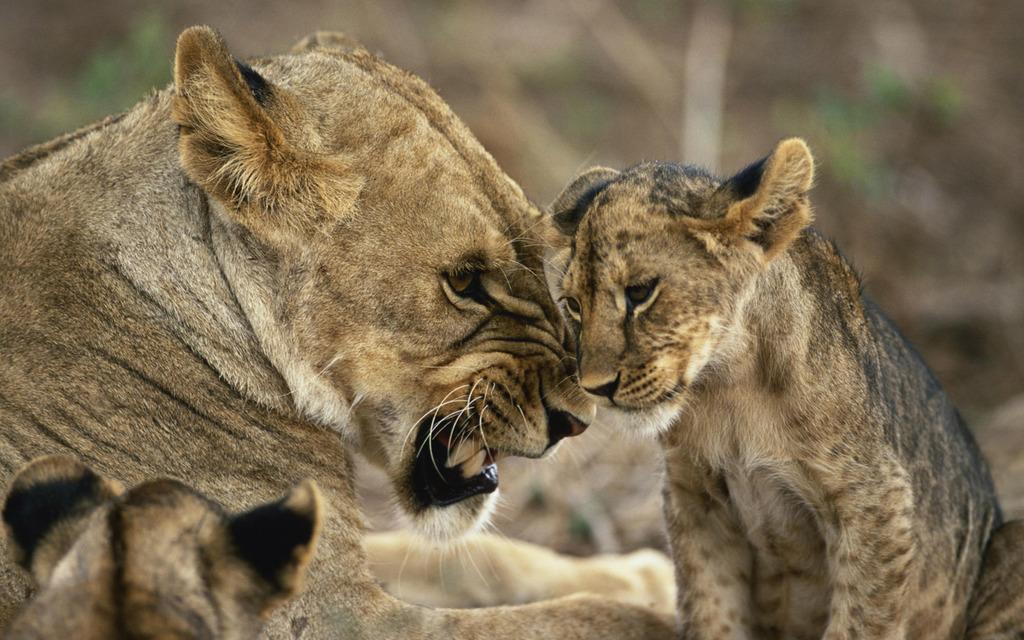In one or two sentences, can you explain what this image depicts? Here in this picture we can see a lion and its cubs present. 